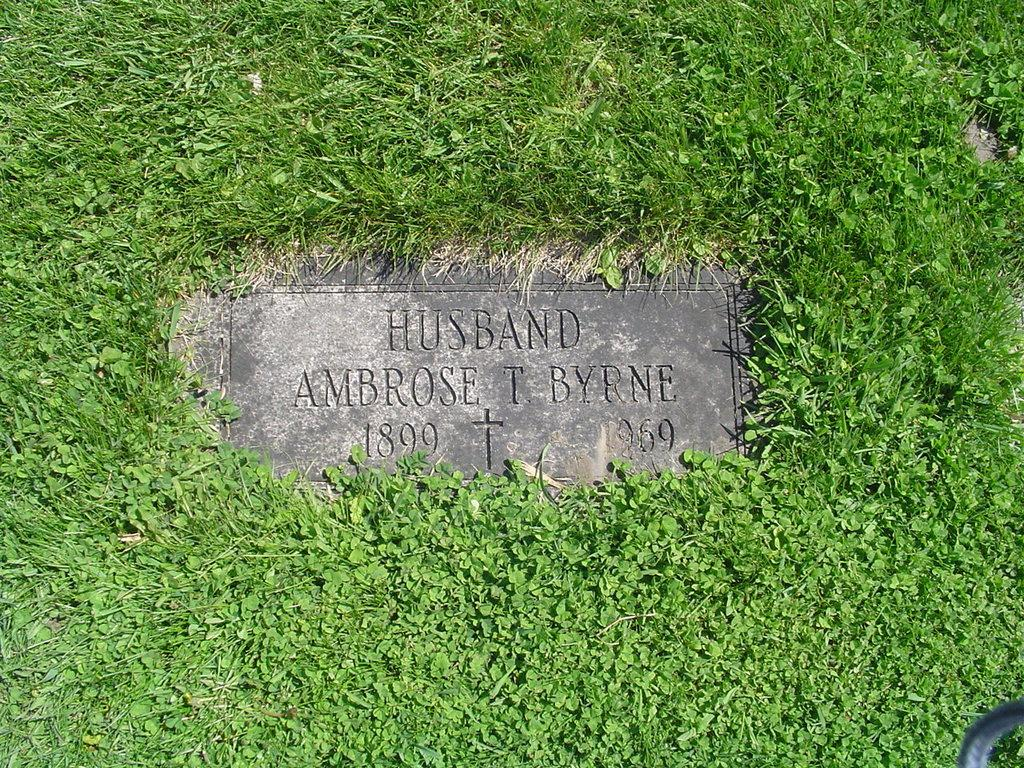What is located in the middle of the image on the ground? There is a stone present on the ground in the middle of the image. What is written or depicted on the stone? There is text carved on the stone. What type of vegetation is visible around the stone? Grass is present around the stone. What type of notebook is lying on the stone in the image? There is no notebook present on the stone in the image. 